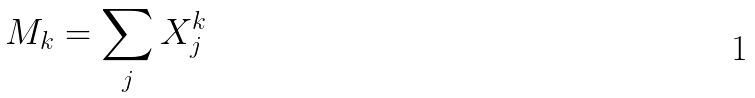Convert formula to latex. <formula><loc_0><loc_0><loc_500><loc_500>M _ { k } = \sum _ { j } X _ { j } ^ { k }</formula> 